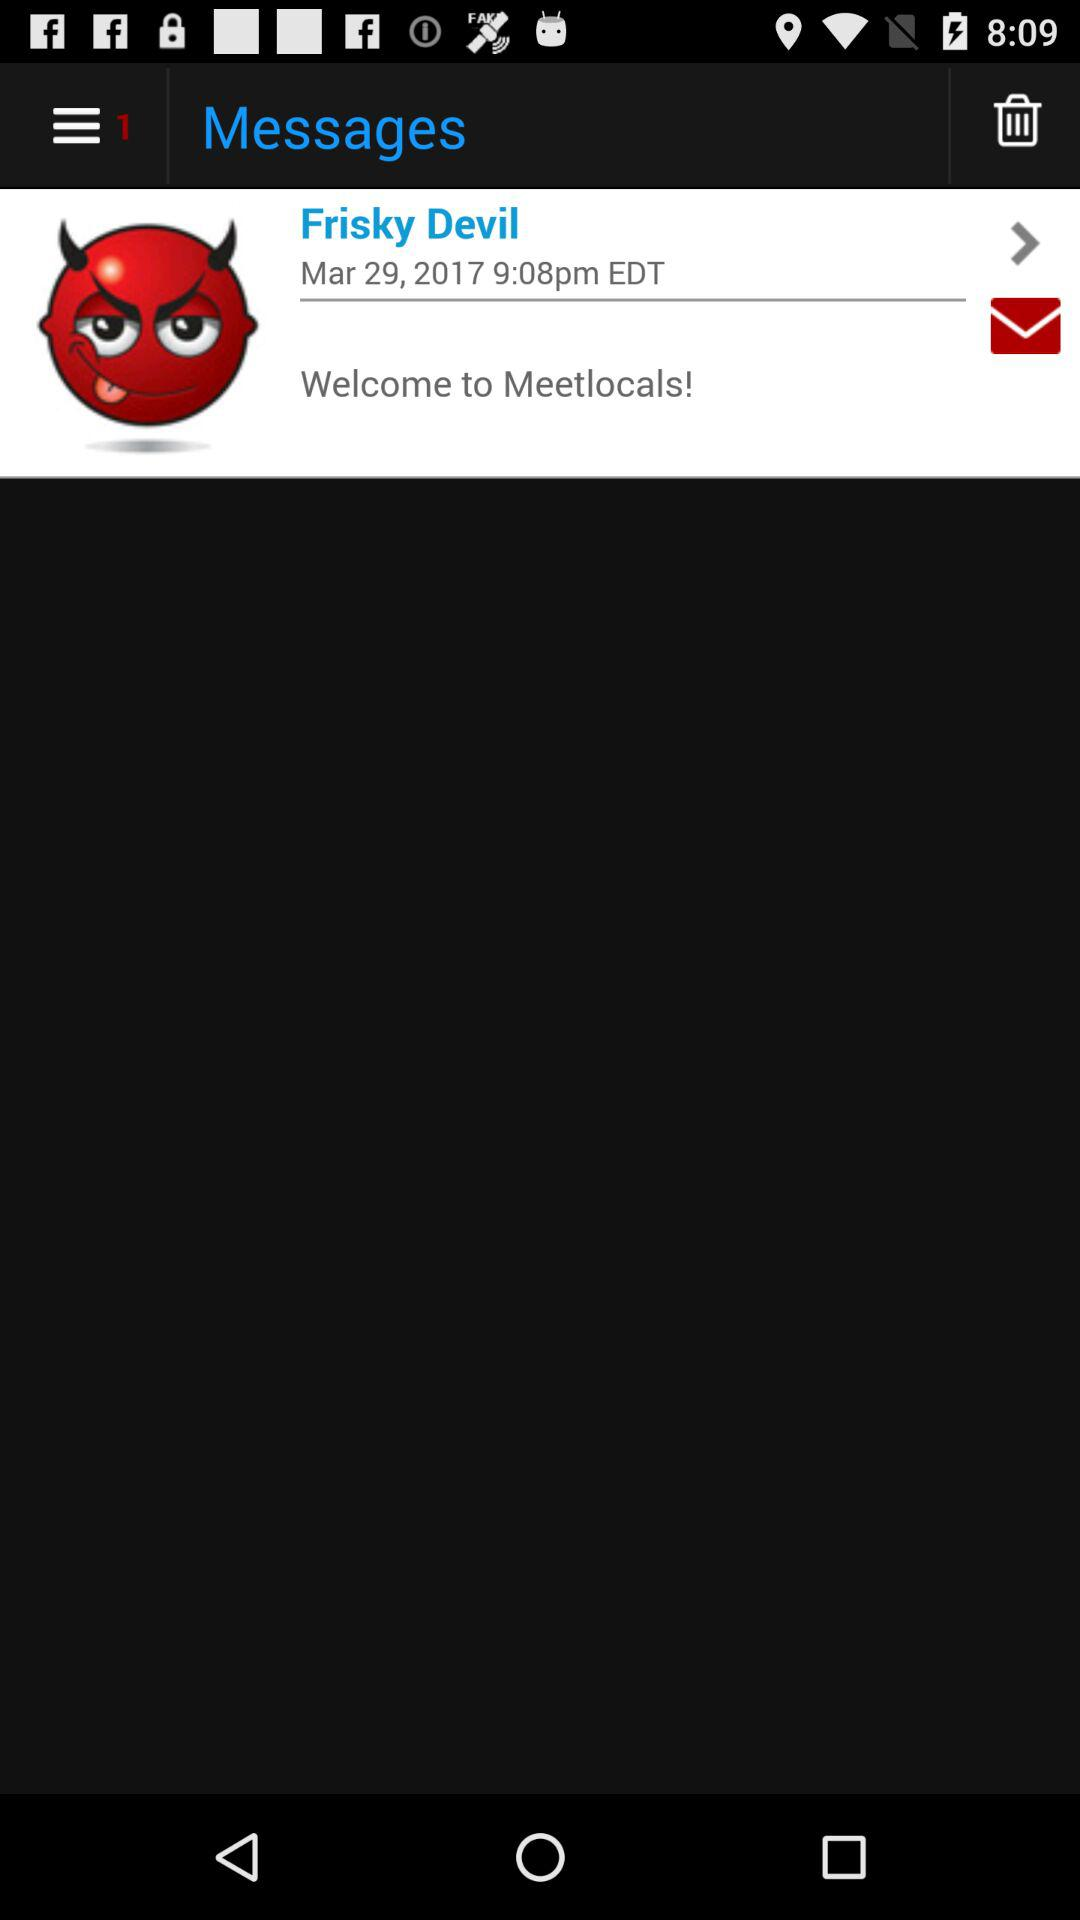How many items are in the trash?
When the provided information is insufficient, respond with <no answer>. <no answer> 